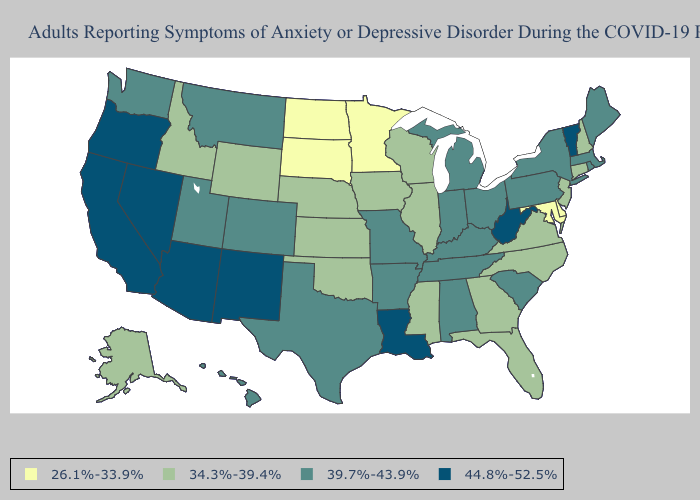What is the value of Mississippi?
Write a very short answer. 34.3%-39.4%. What is the lowest value in the South?
Give a very brief answer. 26.1%-33.9%. Name the states that have a value in the range 26.1%-33.9%?
Answer briefly. Delaware, Maryland, Minnesota, North Dakota, South Dakota. Name the states that have a value in the range 39.7%-43.9%?
Be succinct. Alabama, Arkansas, Colorado, Hawaii, Indiana, Kentucky, Maine, Massachusetts, Michigan, Missouri, Montana, New York, Ohio, Pennsylvania, Rhode Island, South Carolina, Tennessee, Texas, Utah, Washington. What is the value of Indiana?
Concise answer only. 39.7%-43.9%. Among the states that border Ohio , which have the lowest value?
Answer briefly. Indiana, Kentucky, Michigan, Pennsylvania. Among the states that border Kansas , does Colorado have the highest value?
Be succinct. Yes. Among the states that border Wisconsin , does Iowa have the lowest value?
Be succinct. No. Among the states that border Virginia , which have the lowest value?
Quick response, please. Maryland. Is the legend a continuous bar?
Concise answer only. No. Is the legend a continuous bar?
Write a very short answer. No. Among the states that border Missouri , which have the highest value?
Write a very short answer. Arkansas, Kentucky, Tennessee. Among the states that border Ohio , does Indiana have the lowest value?
Quick response, please. Yes. What is the lowest value in states that border Alabama?
Be succinct. 34.3%-39.4%. Name the states that have a value in the range 44.8%-52.5%?
Be succinct. Arizona, California, Louisiana, Nevada, New Mexico, Oregon, Vermont, West Virginia. 